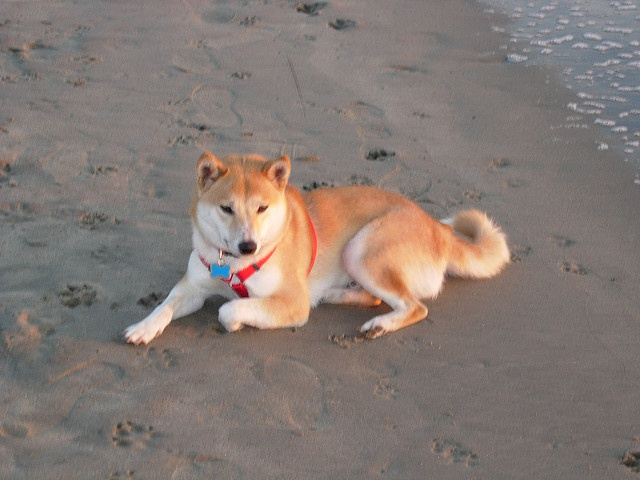Describe the objects in this image and their specific colors. I can see a dog in gray, tan, and darkgray tones in this image. 